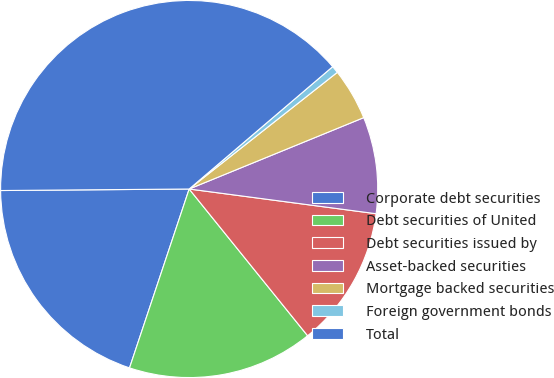Convert chart to OTSL. <chart><loc_0><loc_0><loc_500><loc_500><pie_chart><fcel>Corporate debt securities<fcel>Debt securities of United<fcel>Debt securities issued by<fcel>Asset-backed securities<fcel>Mortgage backed securities<fcel>Foreign government bonds<fcel>Total<nl><fcel>19.75%<fcel>15.93%<fcel>12.1%<fcel>8.27%<fcel>4.44%<fcel>0.62%<fcel>38.89%<nl></chart> 